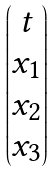Convert formula to latex. <formula><loc_0><loc_0><loc_500><loc_500>\begin{pmatrix} t \\ x _ { 1 } \\ x _ { 2 } \\ x _ { 3 } \\ \end{pmatrix}</formula> 